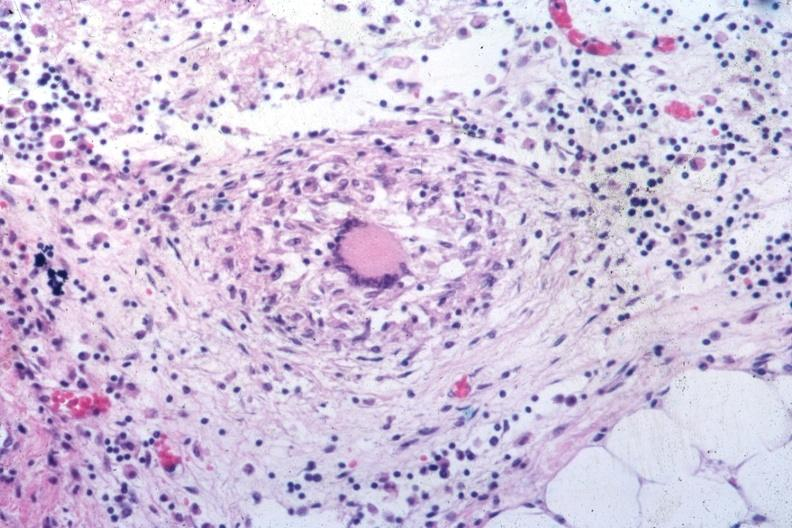what is present?
Answer the question using a single word or phrase. Tuberculosis 